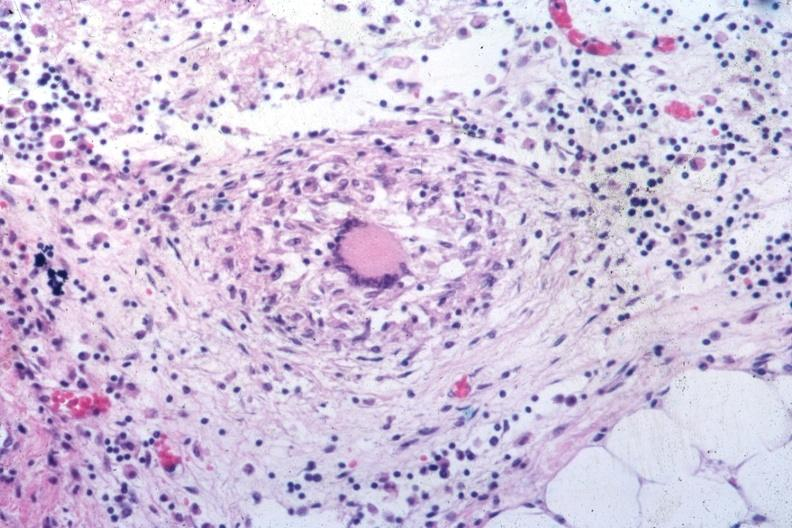what is present?
Answer the question using a single word or phrase. Tuberculosis 